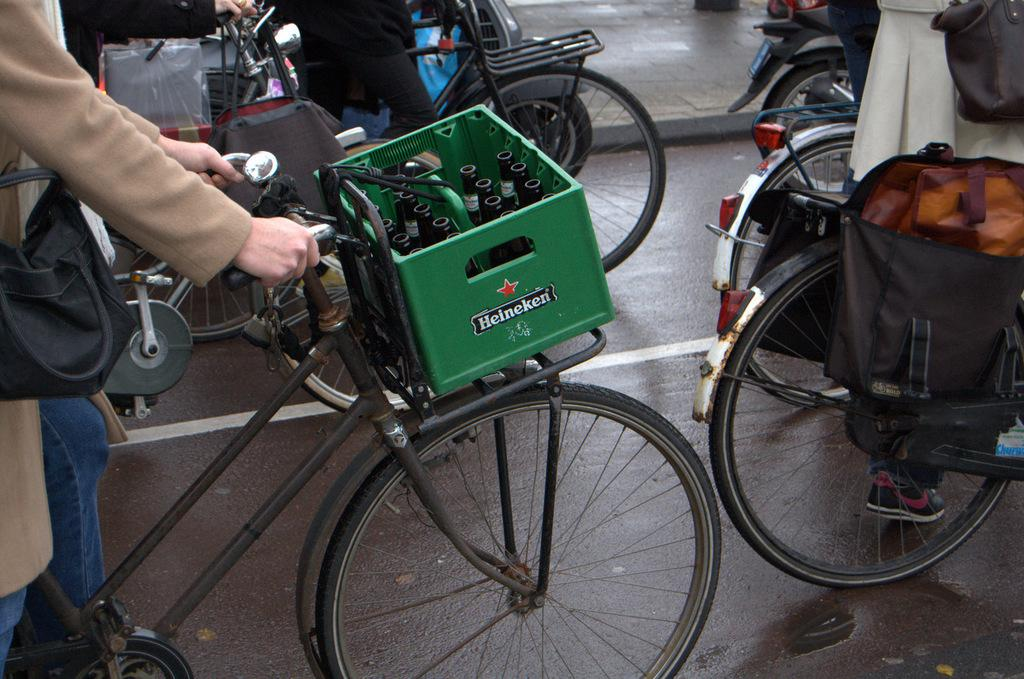What are the persons in the image holding? The persons in the image are holding bicycles. Can you describe the attire of one of the persons in the image? There is a person wearing a bag in the image. What type of setting is depicted in the image? The image depicts a road. What language is the goldfish speaking in the image? There is no goldfish present in the image, so it is not possible to determine what language it might be speaking. 